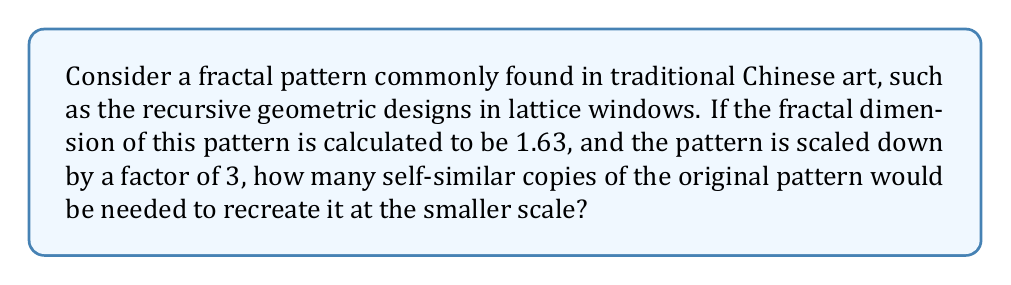Can you solve this math problem? To solve this problem, we need to understand the relationship between fractal dimension, scaling factor, and the number of self-similar copies. This relationship is described by the formula:

$$ N = r^D $$

Where:
$N$ is the number of self-similar copies
$r$ is the reciprocal of the scaling factor
$D$ is the fractal dimension

Given:
- Fractal dimension $D = 1.63$
- Scaling factor = 3

Step 1: Calculate $r$, the reciprocal of the scaling factor:
$$ r = \frac{1}{\text{scaling factor}} = \frac{1}{3} $$

Step 2: Apply the formula $N = r^D$:
$$ N = (\frac{1}{3})^{1.63} $$

Step 3: Calculate the result:
$$ N = 3^{-1.63} \approx 5.2968 $$

Step 4: Round up to the nearest whole number, as we can't have a fractional number of copies:
$$ N \approx 6 $$

This result indicates that when the fractal pattern is scaled down by a factor of 3, approximately 6 self-similar copies of the original pattern would be needed to recreate it at the smaller scale.
Answer: 6 self-similar copies 